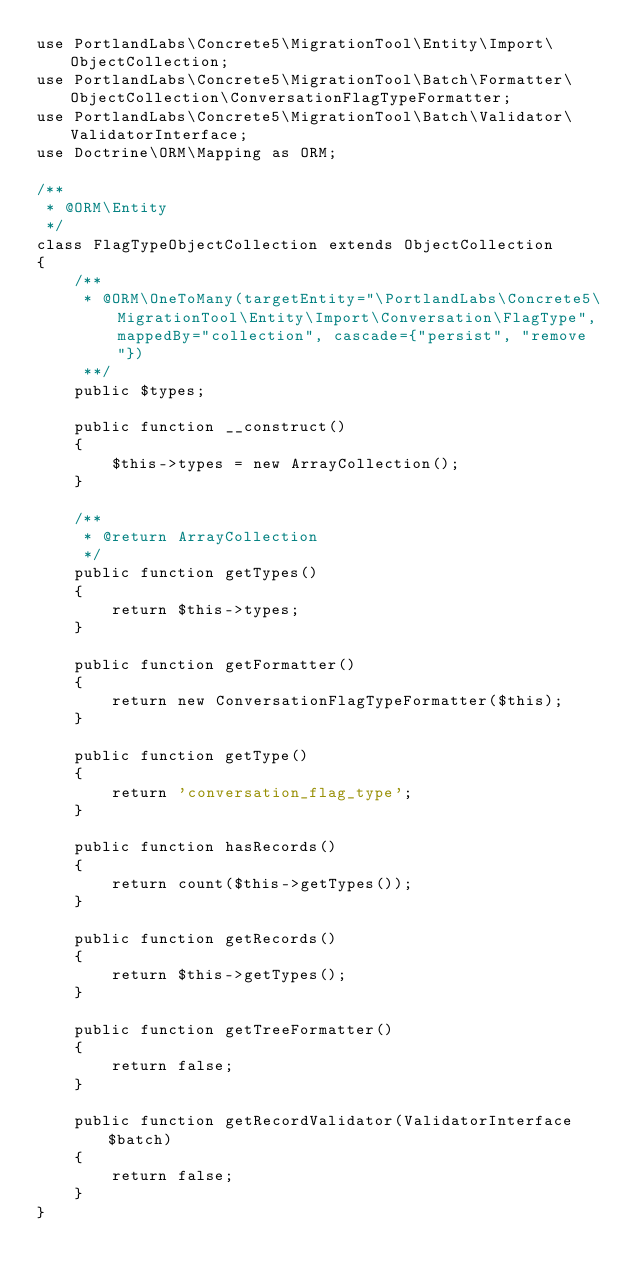<code> <loc_0><loc_0><loc_500><loc_500><_PHP_>use PortlandLabs\Concrete5\MigrationTool\Entity\Import\ObjectCollection;
use PortlandLabs\Concrete5\MigrationTool\Batch\Formatter\ObjectCollection\ConversationFlagTypeFormatter;
use PortlandLabs\Concrete5\MigrationTool\Batch\Validator\ValidatorInterface;
use Doctrine\ORM\Mapping as ORM;

/**
 * @ORM\Entity
 */
class FlagTypeObjectCollection extends ObjectCollection
{
    /**
     * @ORM\OneToMany(targetEntity="\PortlandLabs\Concrete5\MigrationTool\Entity\Import\Conversation\FlagType", mappedBy="collection", cascade={"persist", "remove"})
     **/
    public $types;

    public function __construct()
    {
        $this->types = new ArrayCollection();
    }

    /**
     * @return ArrayCollection
     */
    public function getTypes()
    {
        return $this->types;
    }

    public function getFormatter()
    {
        return new ConversationFlagTypeFormatter($this);
    }

    public function getType()
    {
        return 'conversation_flag_type';
    }

    public function hasRecords()
    {
        return count($this->getTypes());
    }

    public function getRecords()
    {
        return $this->getTypes();
    }

    public function getTreeFormatter()
    {
        return false;
    }

    public function getRecordValidator(ValidatorInterface $batch)
    {
        return false;
    }
}
</code> 